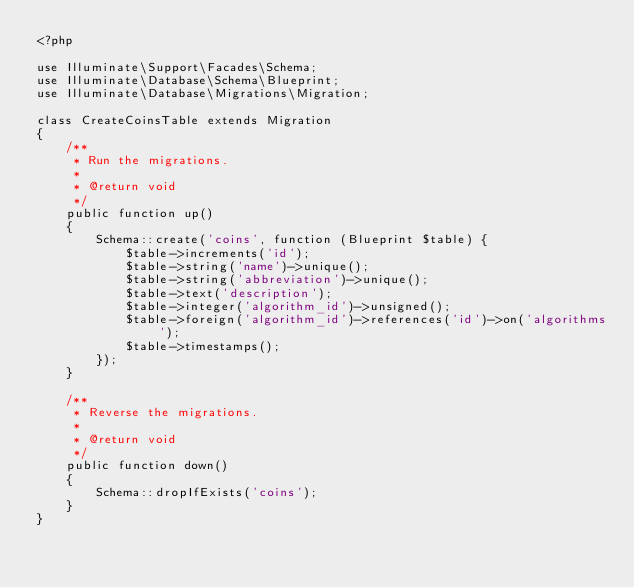<code> <loc_0><loc_0><loc_500><loc_500><_PHP_><?php

use Illuminate\Support\Facades\Schema;
use Illuminate\Database\Schema\Blueprint;
use Illuminate\Database\Migrations\Migration;

class CreateCoinsTable extends Migration
{
    /**
     * Run the migrations.
     *
     * @return void
     */
    public function up()
    {
        Schema::create('coins', function (Blueprint $table) {
            $table->increments('id');
            $table->string('name')->unique();
            $table->string('abbreviation')->unique();
            $table->text('description');
            $table->integer('algorithm_id')->unsigned();
            $table->foreign('algorithm_id')->references('id')->on('algorithms');
            $table->timestamps();
        });
    }

    /**
     * Reverse the migrations.
     *
     * @return void
     */
    public function down()
    {
        Schema::dropIfExists('coins');
    }
}
</code> 